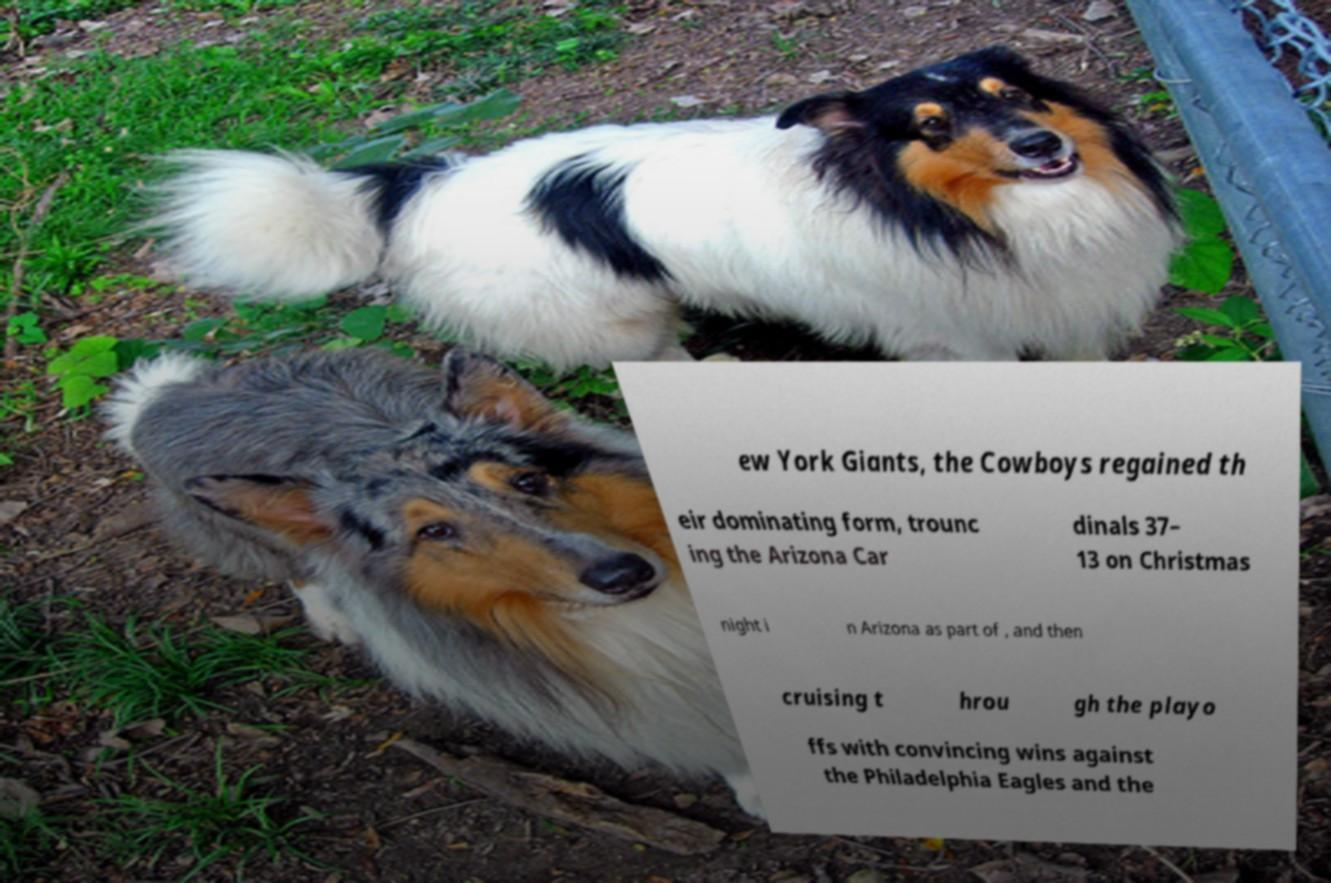I need the written content from this picture converted into text. Can you do that? ew York Giants, the Cowboys regained th eir dominating form, trounc ing the Arizona Car dinals 37– 13 on Christmas night i n Arizona as part of , and then cruising t hrou gh the playo ffs with convincing wins against the Philadelphia Eagles and the 